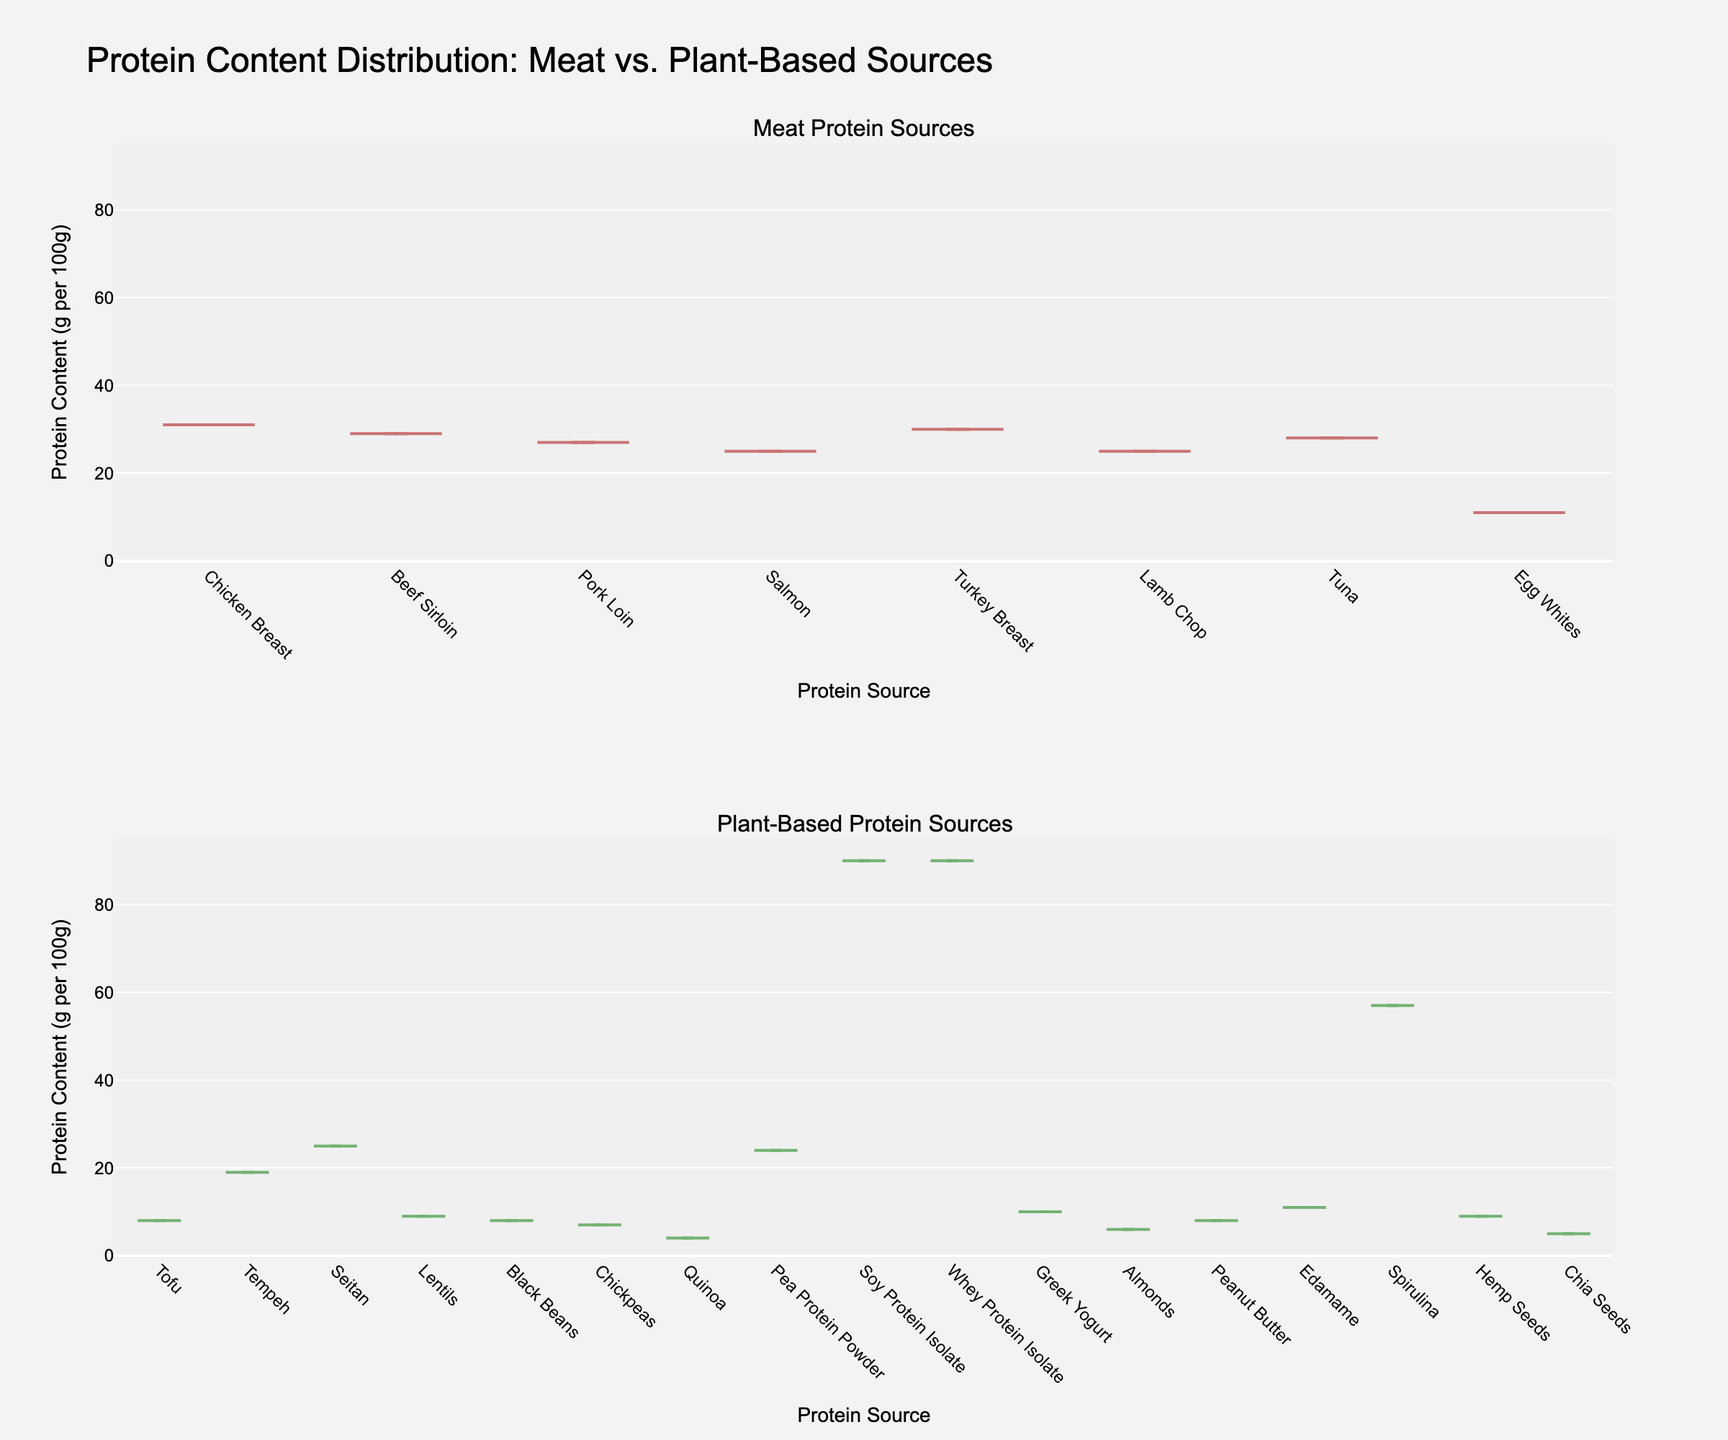What is the title of the figure? The figure's title is usually found at the top of the plot. It provides an overview of what the plot represents. By reading the figure's title, we can see that it is "Protein Content Distribution: Meat vs. Plant-Based Sources".
Answer: Protein Content Distribution: Meat vs. Plant-Based Sources Which protein source has the highest protein content among plant-based sources? By looking at the density plots for plant-based sources in the second subplot, the highest protein content is clearly shown to be Soy Protein Isolate and Whey Protein Isolate.
Answer: Soy Protein Isolate and Whey Protein Isolate What is the protein content range shown on the y-axis? The y-axis represents the protein content in grams per 100 grams. By observing the plot, we can see it ranges from 0 to 95 grams per 100 grams.
Answer: 0 to 95 grams per 100 grams Compare the median protein content of meat sources to plant-based sources. The median protein content is indicated by the meanline visible in both subplots. For meat sources, the median appears to be around 27-28 grams per 100 grams, while for plant-based sources, it varies significantly and is lower overall, but spike for outliers like protein isolates. Soy and whey protein isolates appear to be outliers with very high protein content.
Answer: Meat sources median: ~27-28g, Plant-based sources median: lower but variable Which plant-based protein source has a protein content close to meat sources? Referring to the density plot for plant-based sources, Seitan, Tempeh, and Spirulina are shown to have protein contents that are comparable to some meat sources. They fall within the range of common meat protein contents like lamb chop or salmon.
Answer: Seitan, Tempeh, Spirulina Which sources have both the lowest and highest protein content among all the sources mentioned? Observing both subplots, the lowest protein content among all the sources is Quinoa with 4g, and the highest protein contents are Soy Protein Isolate and Whey Protein Isolate with 90g each.
Answer: Lowest: Quinoa, Highest: Soy Protein Isolate and Whey Protein Isolate How do the widths of the violin plots for meat and plant-based sources compare? The width of a violin plot indicates the density of data points. The meat sources show a more uniform density, implying consistent protein content, while the plant-based sources have a wider range of widths indicating more variance in protein content.
Answer: Meat: Uniform, Plant-based: More variance How many different meat and plant-based sources of protein are shown? The plot reflects individual protein sources for both categories. Counting the labels, there are 8 meat sources and 17 plant-based sources.
Answer: Meat: 8, Plant-based: 17 